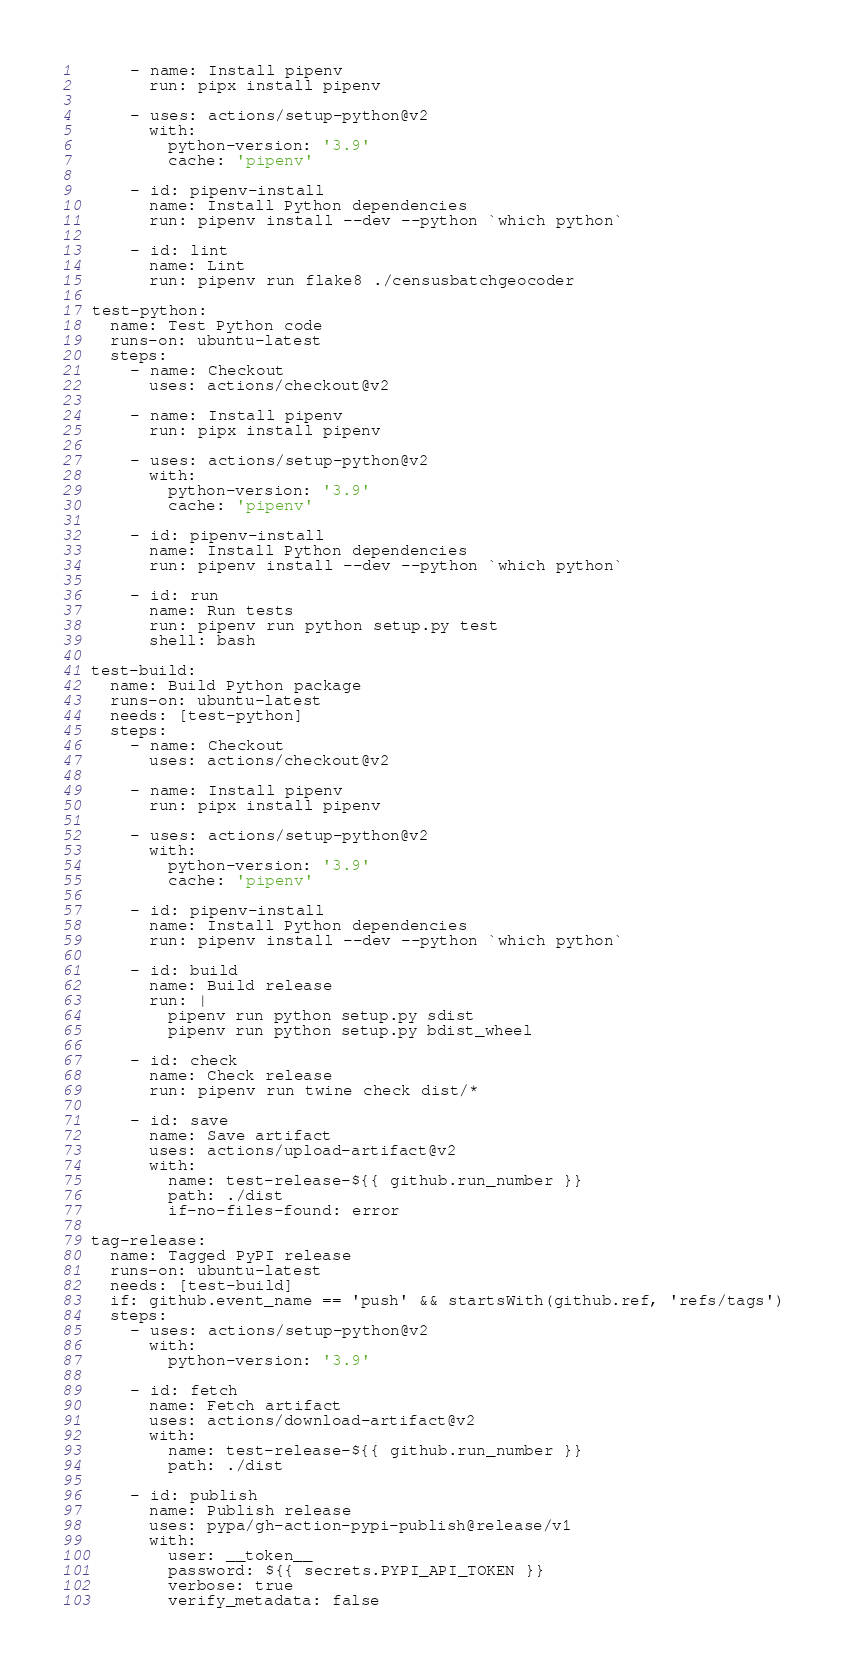Convert code to text. <code><loc_0><loc_0><loc_500><loc_500><_YAML_>
      - name: Install pipenv
        run: pipx install pipenv

      - uses: actions/setup-python@v2
        with:
          python-version: '3.9'
          cache: 'pipenv'

      - id: pipenv-install
        name: Install Python dependencies
        run: pipenv install --dev --python `which python`

      - id: lint
        name: Lint
        run: pipenv run flake8 ./censusbatchgeocoder

  test-python:
    name: Test Python code
    runs-on: ubuntu-latest
    steps:
      - name: Checkout
        uses: actions/checkout@v2

      - name: Install pipenv
        run: pipx install pipenv

      - uses: actions/setup-python@v2
        with:
          python-version: '3.9'
          cache: 'pipenv'

      - id: pipenv-install
        name: Install Python dependencies
        run: pipenv install --dev --python `which python`

      - id: run
        name: Run tests
        run: pipenv run python setup.py test
        shell: bash

  test-build:
    name: Build Python package
    runs-on: ubuntu-latest
    needs: [test-python]
    steps:
      - name: Checkout
        uses: actions/checkout@v2

      - name: Install pipenv
        run: pipx install pipenv

      - uses: actions/setup-python@v2
        with:
          python-version: '3.9'
          cache: 'pipenv'

      - id: pipenv-install
        name: Install Python dependencies
        run: pipenv install --dev --python `which python`

      - id: build
        name: Build release
        run: |
          pipenv run python setup.py sdist
          pipenv run python setup.py bdist_wheel

      - id: check
        name: Check release
        run: pipenv run twine check dist/*

      - id: save
        name: Save artifact
        uses: actions/upload-artifact@v2
        with:
          name: test-release-${{ github.run_number }}
          path: ./dist
          if-no-files-found: error

  tag-release:
    name: Tagged PyPI release
    runs-on: ubuntu-latest
    needs: [test-build]
    if: github.event_name == 'push' && startsWith(github.ref, 'refs/tags')
    steps:
      - uses: actions/setup-python@v2
        with:
          python-version: '3.9'

      - id: fetch
        name: Fetch artifact
        uses: actions/download-artifact@v2
        with:
          name: test-release-${{ github.run_number }}
          path: ./dist

      - id: publish
        name: Publish release
        uses: pypa/gh-action-pypi-publish@release/v1
        with:
          user: __token__
          password: ${{ secrets.PYPI_API_TOKEN }}
          verbose: true
          verify_metadata: false
</code> 